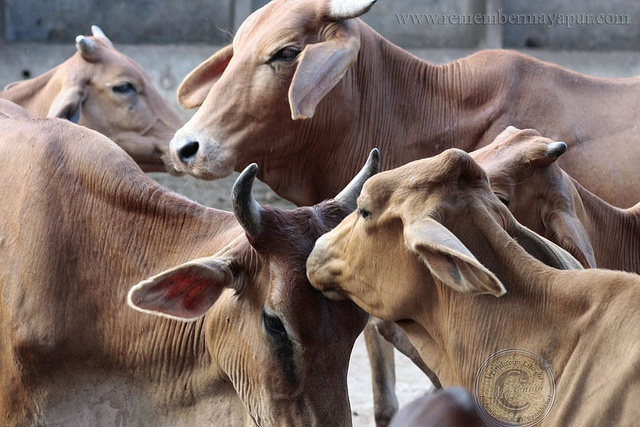Describe the objects in this image and their specific colors. I can see cow in black, gray, and maroon tones, cow in black, darkgray, gray, and maroon tones, cow in black, gray, and tan tones, cow in black, darkgray, gray, and lightgray tones, and cow in black, gray, and darkgray tones in this image. 